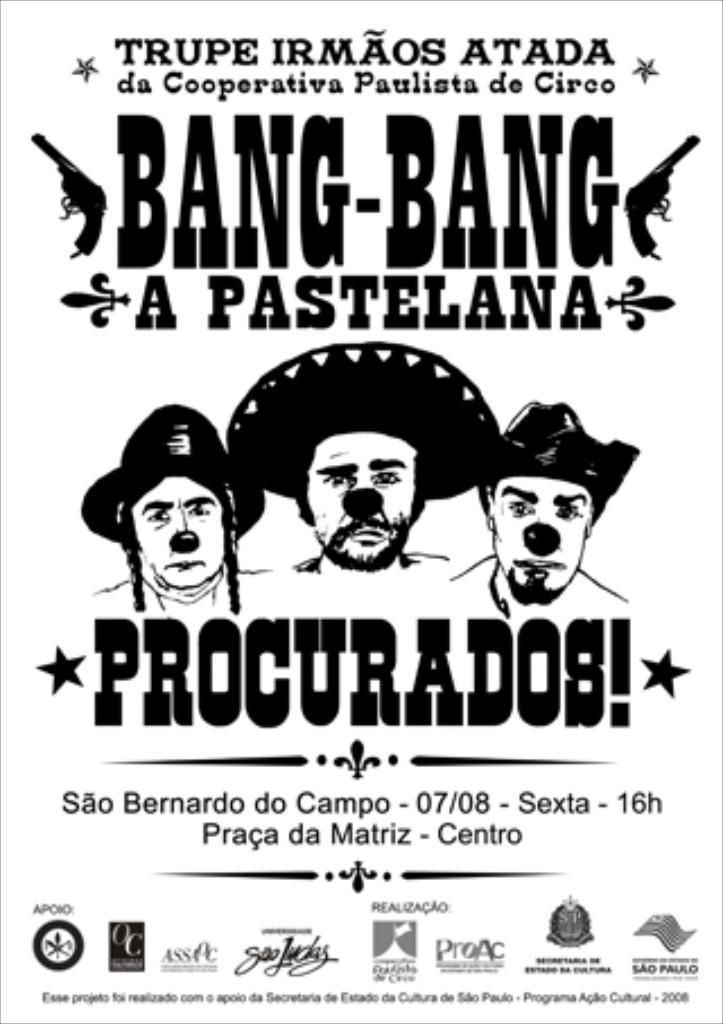How many people are in the image? There are three persons in the image. What else can be seen in the image besides the people? There is text and logos in the image. Can you tell me how many socks are visible in the image? There are no socks present in the image. What type of shock can be seen in the image? There is no shock present in the image. 